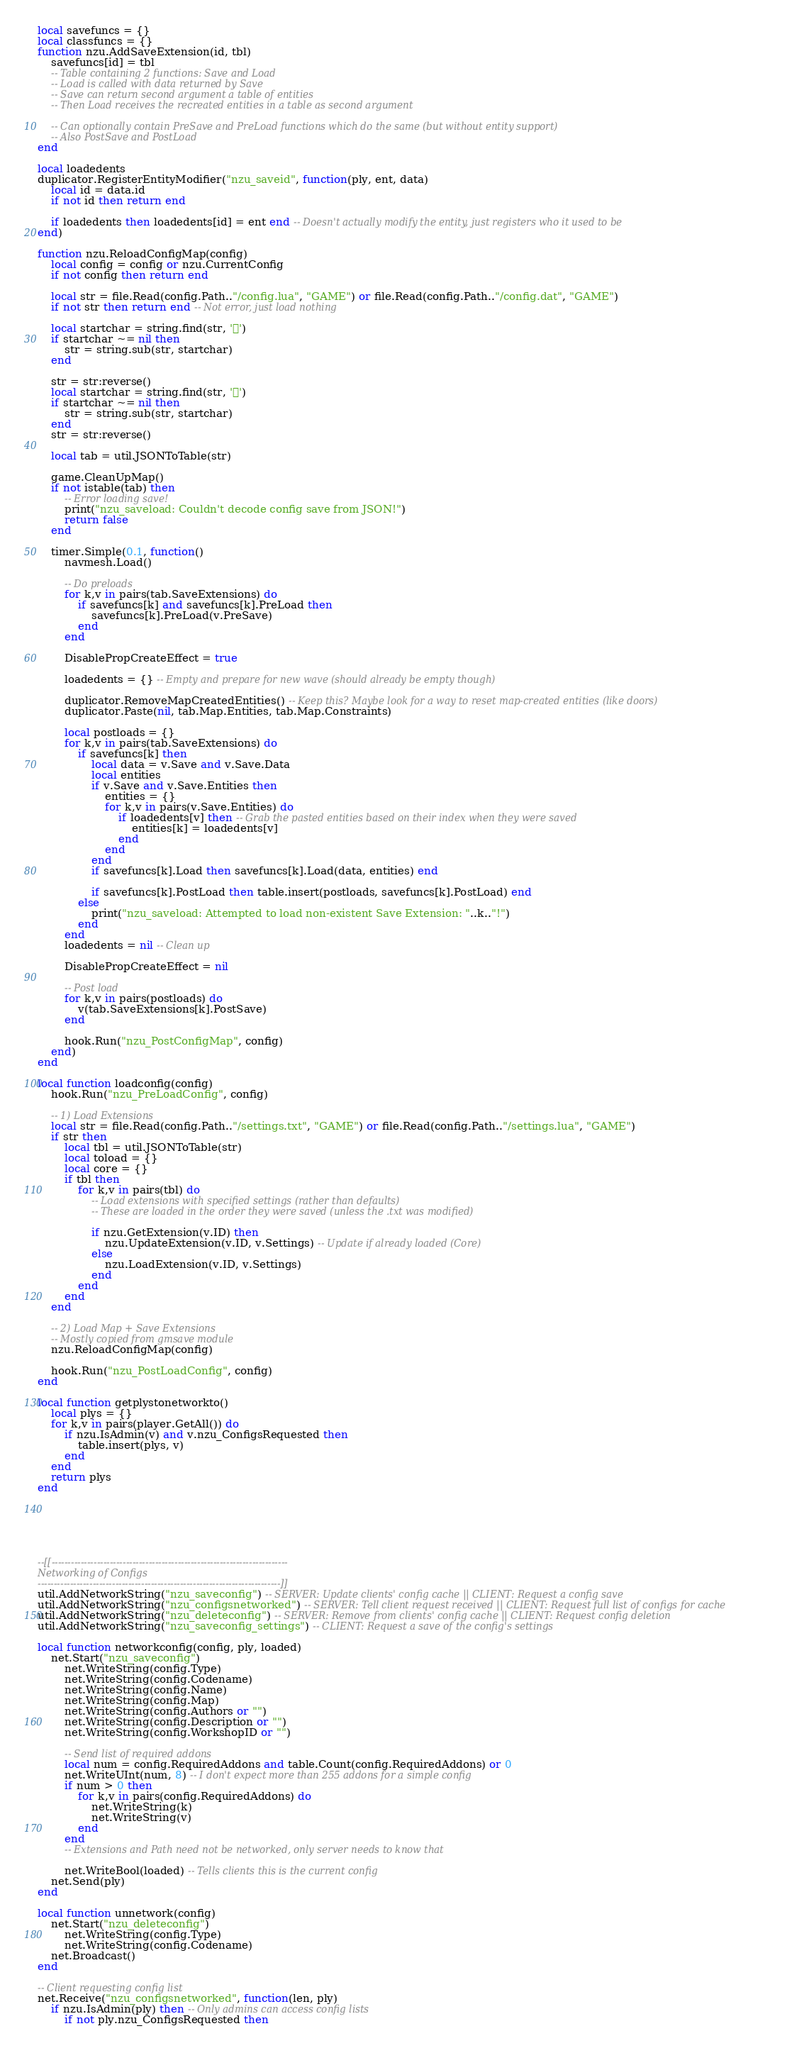Convert code to text. <code><loc_0><loc_0><loc_500><loc_500><_Lua_>local savefuncs = {}
local classfuncs = {}
function nzu.AddSaveExtension(id, tbl)
	savefuncs[id] = tbl
	-- Table containing 2 functions: Save and Load
	-- Load is called with data returned by Save
	-- Save can return second argument a table of entities
	-- Then Load receives the recreated entities in a table as second argument
	
	-- Can optionally contain PreSave and PreLoad functions which do the same (but without entity support)
	-- Also PostSave and PostLoad
end

local loadedents
duplicator.RegisterEntityModifier("nzu_saveid", function(ply, ent, data)
	local id = data.id
	if not id then return end
	
	if loadedents then loadedents[id] = ent end -- Doesn't actually modify the entity, just registers who it used to be
end)

function nzu.ReloadConfigMap(config)
	local config = config or nzu.CurrentConfig
	if not config then return end
	
	local str = file.Read(config.Path.."/config.lua", "GAME") or file.Read(config.Path.."/config.dat", "GAME")
	if not str then return end -- Not error, just load nothing
	
	local startchar = string.find(str, '')
	if startchar ~= nil then
		str = string.sub(str, startchar)
	end
	
	str = str:reverse()
	local startchar = string.find(str, '')
	if startchar ~= nil then
		str = string.sub(str, startchar)
	end
	str = str:reverse()

	local tab = util.JSONToTable(str)

	game.CleanUpMap()
	if not istable(tab) then
		-- Error loading save!
		print("nzu_saveload: Couldn't decode config save from JSON!")
		return false
	end

	timer.Simple(0.1, function()
		navmesh.Load()
	
		-- Do preloads
		for k,v in pairs(tab.SaveExtensions) do
			if savefuncs[k] and savefuncs[k].PreLoad then
				savefuncs[k].PreLoad(v.PreSave)
			end
		end

		DisablePropCreateEffect = true

		loadedents = {} -- Empty and prepare for new wave (should already be empty though)
		
		duplicator.RemoveMapCreatedEntities() -- Keep this? Maybe look for a way to reset map-created entities (like doors)
		duplicator.Paste(nil, tab.Map.Entities, tab.Map.Constraints)
		
		local postloads = {}
		for k,v in pairs(tab.SaveExtensions) do
			if savefuncs[k] then
				local data = v.Save and v.Save.Data
				local entities
				if v.Save and v.Save.Entities then
					entities = {}
					for k,v in pairs(v.Save.Entities) do
						if loadedents[v] then -- Grab the pasted entities based on their index when they were saved
							entities[k] = loadedents[v]
						end
					end
				end
				if savefuncs[k].Load then savefuncs[k].Load(data, entities) end

				if savefuncs[k].PostLoad then table.insert(postloads, savefuncs[k].PostLoad) end
			else
				print("nzu_saveload: Attempted to load non-existent Save Extension: "..k.."!")
			end
		end
		loadedents = nil -- Clean up
		
		DisablePropCreateEffect = nil

		-- Post load
		for k,v in pairs(postloads) do
			v(tab.SaveExtensions[k].PostSave)
		end
		
		hook.Run("nzu_PostConfigMap", config)
	end)
end

local function loadconfig(config)
	hook.Run("nzu_PreLoadConfig", config)

	-- 1) Load Extensions
	local str = file.Read(config.Path.."/settings.txt", "GAME") or file.Read(config.Path.."/settings.lua", "GAME")
	if str then
		local tbl = util.JSONToTable(str)
		local toload = {}
		local core = {}
		if tbl then
			for k,v in pairs(tbl) do
				-- Load extensions with specified settings (rather than defaults)
				-- These are loaded in the order they were saved (unless the .txt was modified)

				if nzu.GetExtension(v.ID) then
					nzu.UpdateExtension(v.ID, v.Settings) -- Update if already loaded (Core)
				else
					nzu.LoadExtension(v.ID, v.Settings)
				end
			end
		end
	end

	-- 2) Load Map + Save Extensions
	-- Mostly copied from gmsave module
	nzu.ReloadConfigMap(config)

	hook.Run("nzu_PostLoadConfig", config)
end

local function getplystonetworkto()
	local plys = {}
	for k,v in pairs(player.GetAll()) do
		if nzu.IsAdmin(v) and v.nzu_ConfigsRequested then
			table.insert(plys, v)
		end
	end
	return plys
end






--[[-------------------------------------------------------------------------
Networking of Configs
---------------------------------------------------------------------------]]
util.AddNetworkString("nzu_saveconfig") -- SERVER: Update clients' config cache || CLIENT: Request a config save
util.AddNetworkString("nzu_configsnetworked") -- SERVER: Tell client request received || CLIENT: Request full list of configs for cache
util.AddNetworkString("nzu_deleteconfig") -- SERVER: Remove from clients' config cache || CLIENT: Request config deletion
util.AddNetworkString("nzu_saveconfig_settings") -- CLIENT: Request a save of the config's settings

local function networkconfig(config, ply, loaded)
	net.Start("nzu_saveconfig")
		net.WriteString(config.Type)
		net.WriteString(config.Codename)
		net.WriteString(config.Name)
		net.WriteString(config.Map)
		net.WriteString(config.Authors or "")
		net.WriteString(config.Description or "")
		net.WriteString(config.WorkshopID or "")

		-- Send list of required addons
		local num = config.RequiredAddons and table.Count(config.RequiredAddons) or 0
		net.WriteUInt(num, 8) -- I don't expect more than 255 addons for a simple config
		if num > 0 then
			for k,v in pairs(config.RequiredAddons) do
				net.WriteString(k)
				net.WriteString(v)
			end
		end
		-- Extensions and Path need not be networked, only server needs to know that

		net.WriteBool(loaded) -- Tells clients this is the current config
	net.Send(ply)
end

local function unnetwork(config)
	net.Start("nzu_deleteconfig")
		net.WriteString(config.Type)
		net.WriteString(config.Codename)
	net.Broadcast()
end

-- Client requesting config list
net.Receive("nzu_configsnetworked", function(len, ply)
	if nzu.IsAdmin(ply) then -- Only admins can access config lists
		if not ply.nzu_ConfigsRequested then</code> 